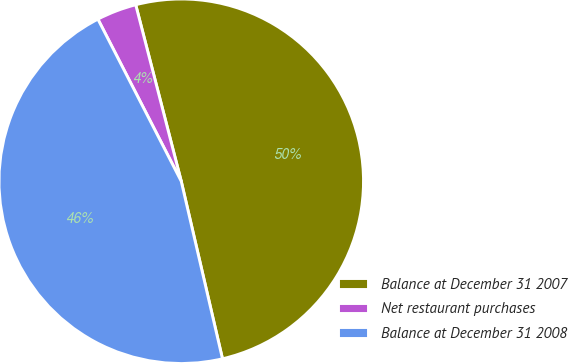Convert chart. <chart><loc_0><loc_0><loc_500><loc_500><pie_chart><fcel>Balance at December 31 2007<fcel>Net restaurant purchases<fcel>Balance at December 31 2008<nl><fcel>50.38%<fcel>3.54%<fcel>46.07%<nl></chart> 